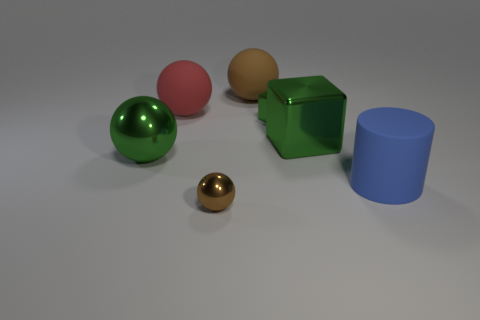How do the objects in the image appear in terms of texture and material? The objects exhibit a variety of textures and appear to be made from different materials. The green and pink spheres have a shiny surface, suggesting a smooth, metallic texture. The small brown sphere has a similar sheen and likely shares the same material. The green cube and blue cylinder have a matte finish, indicating a non-metallic, perhaps plastic, composition. 